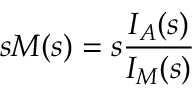<formula> <loc_0><loc_0><loc_500><loc_500>s M ( s ) = s \frac { I _ { A } ( s ) } { I _ { M } ( s ) }</formula> 